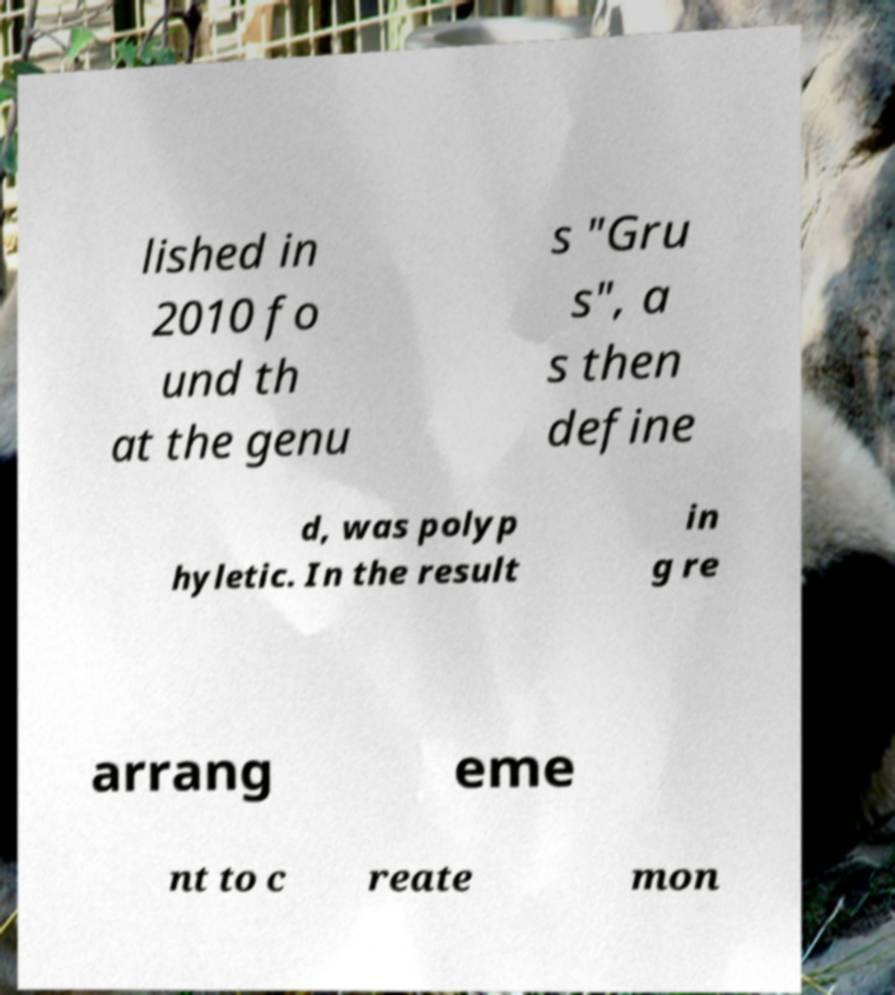Could you assist in decoding the text presented in this image and type it out clearly? lished in 2010 fo und th at the genu s "Gru s", a s then define d, was polyp hyletic. In the result in g re arrang eme nt to c reate mon 